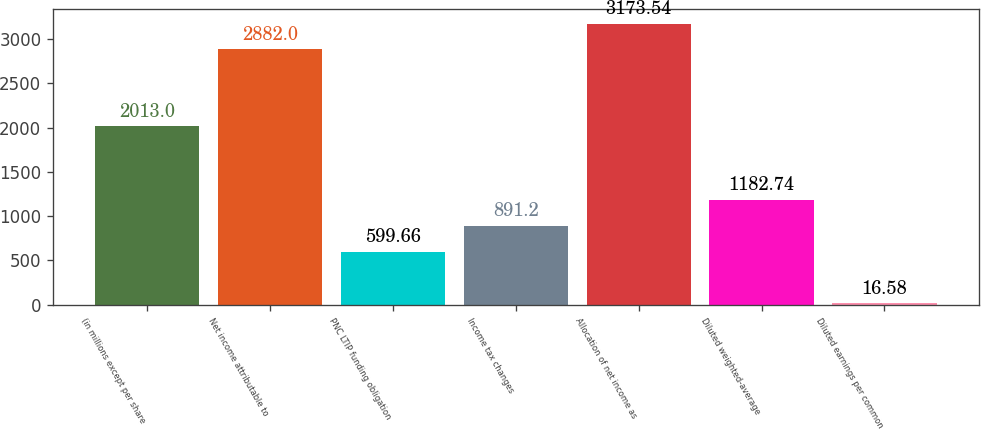Convert chart. <chart><loc_0><loc_0><loc_500><loc_500><bar_chart><fcel>(in millions except per share<fcel>Net income attributable to<fcel>PNC LTIP funding obligation<fcel>Income tax changes<fcel>Allocation of net income as<fcel>Diluted weighted-average<fcel>Diluted earnings per common<nl><fcel>2013<fcel>2882<fcel>599.66<fcel>891.2<fcel>3173.54<fcel>1182.74<fcel>16.58<nl></chart> 